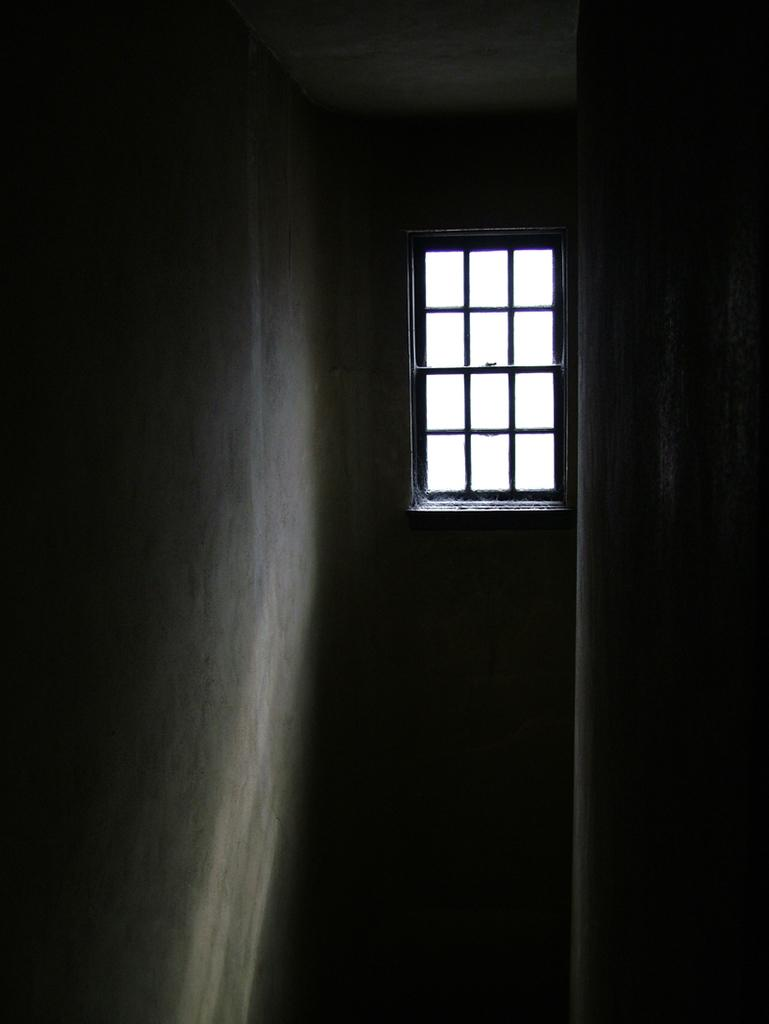What is the overall lighting condition in the room in the image? The room in the image is dark. Is there any source of natural light in the image? Yes, there is a window in the image. What objects can be seen in the room that are related to the window? There are rods visible in the image, which are likely related to the window, such as curtain rods or blinds. What type of border is present around the window in the image? There is no border present around the window in the image. What color is the stem of the plant next to the window? There is no plant or stem visible in the image. 